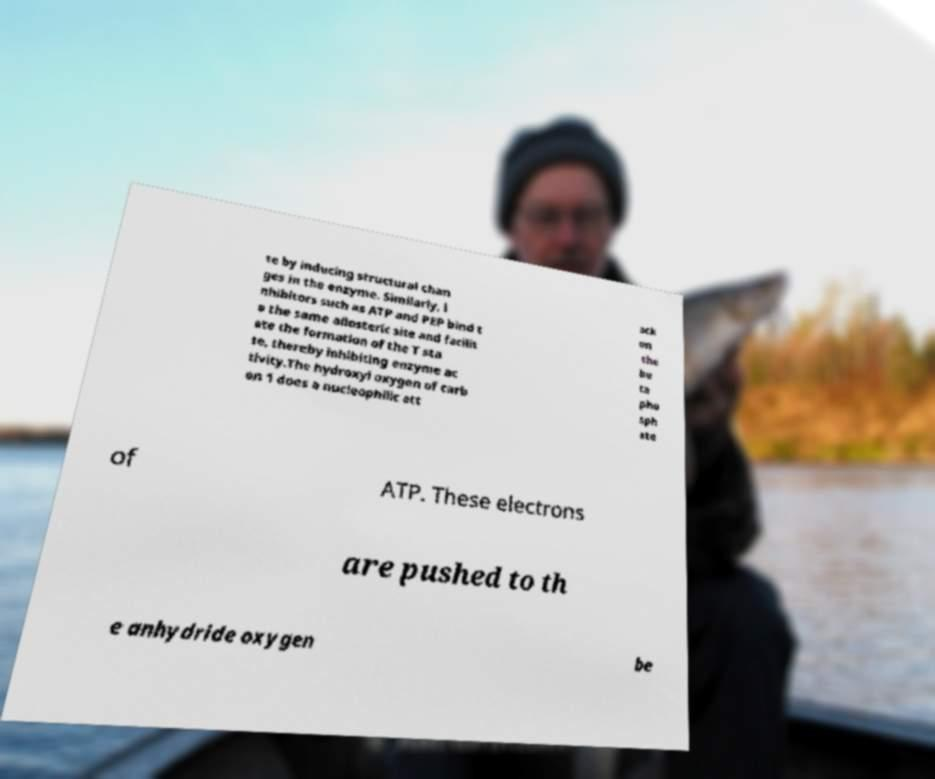Please read and relay the text visible in this image. What does it say? te by inducing structural chan ges in the enzyme. Similarly, i nhibitors such as ATP and PEP bind t o the same allosteric site and facilit ate the formation of the T sta te, thereby inhibiting enzyme ac tivity.The hydroxyl oxygen of carb on 1 does a nucleophilic att ack on the be ta pho sph ate of ATP. These electrons are pushed to th e anhydride oxygen be 